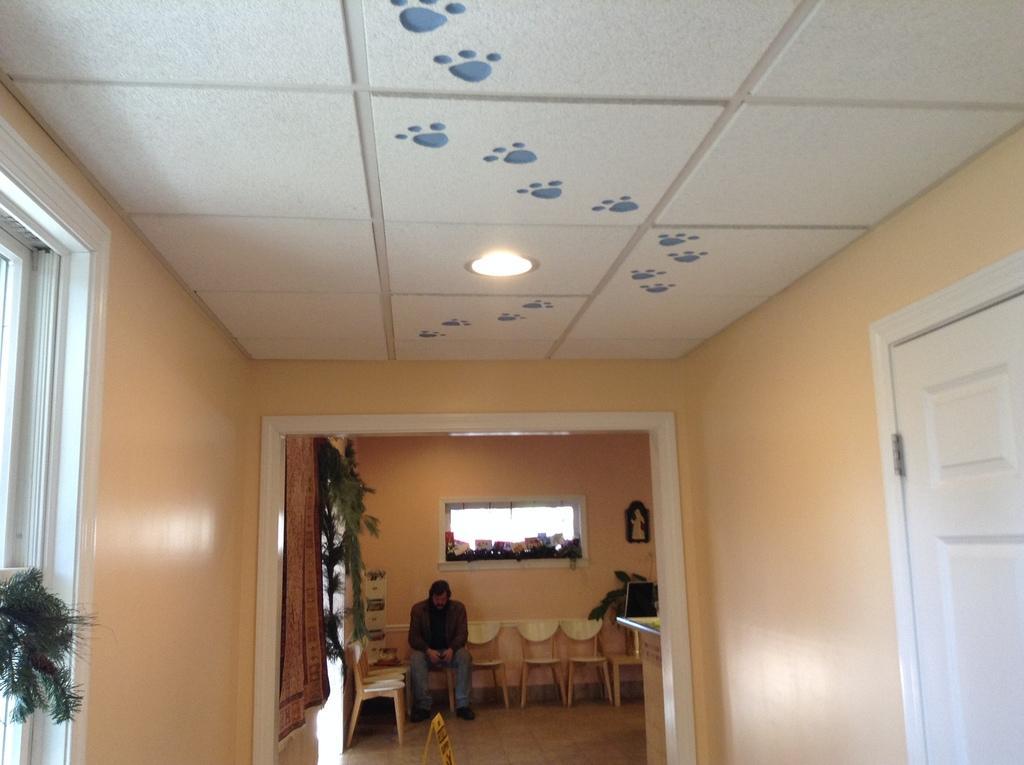Could you give a brief overview of what you see in this image? In this image I can see the inner view of the house. Inside the house I can see the person sitting on the chair. I can see few more chairs and the plant. In the background I can see the window and an object to the wall. To the right I can see the door and to the left I can see an object looks like plant. 